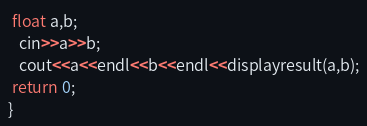Convert code to text. <code><loc_0><loc_0><loc_500><loc_500><_C++_> float a,b;
   cin>>a>>b;
   cout<<a<<endl<<b<<endl<<displayresult(a,b);
 return 0;
}</code> 